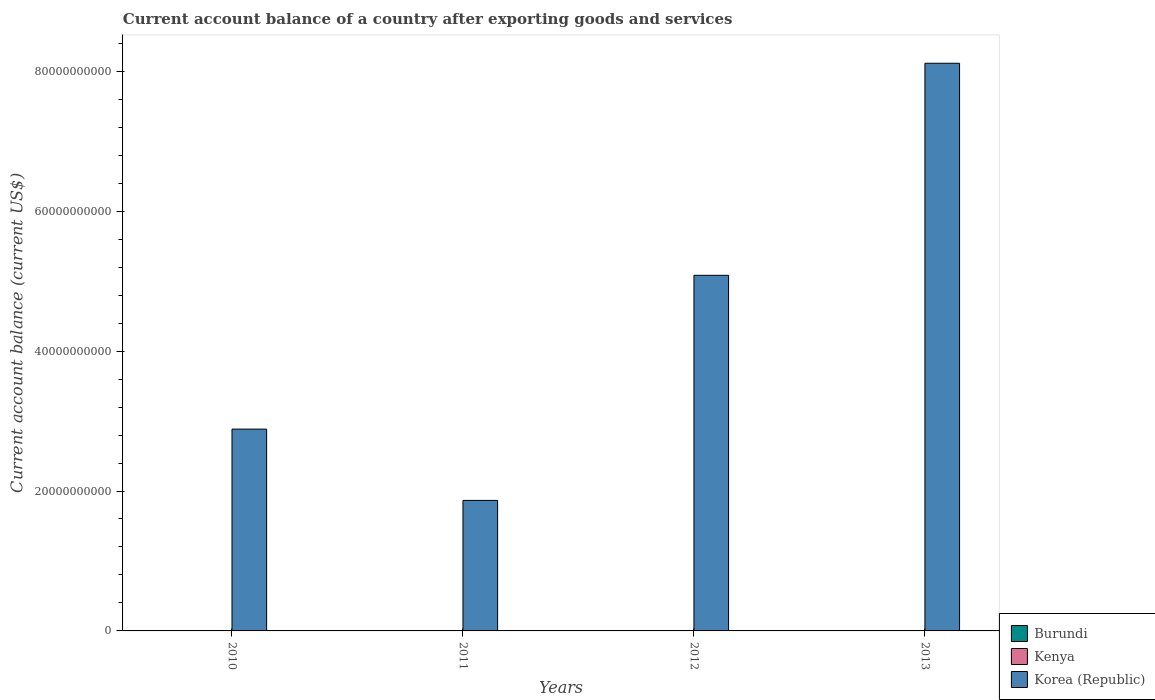How many different coloured bars are there?
Give a very brief answer. 1. Are the number of bars per tick equal to the number of legend labels?
Offer a terse response. No. How many bars are there on the 3rd tick from the left?
Keep it short and to the point. 1. How many bars are there on the 1st tick from the right?
Offer a very short reply. 1. What is the account balance in Korea (Republic) in 2013?
Your answer should be compact. 8.11e+1. Across all years, what is the maximum account balance in Korea (Republic)?
Ensure brevity in your answer.  8.11e+1. Across all years, what is the minimum account balance in Kenya?
Give a very brief answer. 0. What is the total account balance in Burundi in the graph?
Offer a terse response. 0. What is the difference between the account balance in Korea (Republic) in 2011 and that in 2012?
Provide a succinct answer. -3.22e+1. What is the difference between the account balance in Kenya in 2011 and the account balance in Korea (Republic) in 2013?
Provide a succinct answer. -8.11e+1. What is the average account balance in Kenya per year?
Offer a very short reply. 0. In how many years, is the account balance in Kenya greater than 24000000000 US$?
Make the answer very short. 0. What is the ratio of the account balance in Korea (Republic) in 2010 to that in 2011?
Keep it short and to the point. 1.55. Is the account balance in Korea (Republic) in 2010 less than that in 2011?
Your answer should be very brief. No. What is the difference between the highest and the second highest account balance in Korea (Republic)?
Make the answer very short. 3.03e+1. What is the difference between the highest and the lowest account balance in Korea (Republic)?
Your response must be concise. 6.25e+1. In how many years, is the account balance in Burundi greater than the average account balance in Burundi taken over all years?
Offer a very short reply. 0. How many bars are there?
Your response must be concise. 4. Are all the bars in the graph horizontal?
Ensure brevity in your answer.  No. What is the difference between two consecutive major ticks on the Y-axis?
Your answer should be compact. 2.00e+1. Where does the legend appear in the graph?
Provide a short and direct response. Bottom right. How many legend labels are there?
Keep it short and to the point. 3. What is the title of the graph?
Your answer should be compact. Current account balance of a country after exporting goods and services. Does "Kyrgyz Republic" appear as one of the legend labels in the graph?
Offer a terse response. No. What is the label or title of the X-axis?
Provide a succinct answer. Years. What is the label or title of the Y-axis?
Keep it short and to the point. Current account balance (current US$). What is the Current account balance (current US$) of Korea (Republic) in 2010?
Offer a very short reply. 2.89e+1. What is the Current account balance (current US$) in Kenya in 2011?
Provide a succinct answer. 0. What is the Current account balance (current US$) in Korea (Republic) in 2011?
Offer a terse response. 1.87e+1. What is the Current account balance (current US$) of Burundi in 2012?
Ensure brevity in your answer.  0. What is the Current account balance (current US$) in Kenya in 2012?
Make the answer very short. 0. What is the Current account balance (current US$) in Korea (Republic) in 2012?
Keep it short and to the point. 5.08e+1. What is the Current account balance (current US$) of Kenya in 2013?
Offer a terse response. 0. What is the Current account balance (current US$) of Korea (Republic) in 2013?
Provide a succinct answer. 8.11e+1. Across all years, what is the maximum Current account balance (current US$) of Korea (Republic)?
Offer a terse response. 8.11e+1. Across all years, what is the minimum Current account balance (current US$) of Korea (Republic)?
Ensure brevity in your answer.  1.87e+1. What is the total Current account balance (current US$) of Kenya in the graph?
Your response must be concise. 0. What is the total Current account balance (current US$) in Korea (Republic) in the graph?
Your answer should be very brief. 1.79e+11. What is the difference between the Current account balance (current US$) in Korea (Republic) in 2010 and that in 2011?
Provide a short and direct response. 1.02e+1. What is the difference between the Current account balance (current US$) in Korea (Republic) in 2010 and that in 2012?
Provide a short and direct response. -2.20e+1. What is the difference between the Current account balance (current US$) in Korea (Republic) in 2010 and that in 2013?
Your response must be concise. -5.23e+1. What is the difference between the Current account balance (current US$) of Korea (Republic) in 2011 and that in 2012?
Make the answer very short. -3.22e+1. What is the difference between the Current account balance (current US$) in Korea (Republic) in 2011 and that in 2013?
Make the answer very short. -6.25e+1. What is the difference between the Current account balance (current US$) in Korea (Republic) in 2012 and that in 2013?
Provide a succinct answer. -3.03e+1. What is the average Current account balance (current US$) of Burundi per year?
Provide a succinct answer. 0. What is the average Current account balance (current US$) in Korea (Republic) per year?
Provide a succinct answer. 4.49e+1. What is the ratio of the Current account balance (current US$) in Korea (Republic) in 2010 to that in 2011?
Make the answer very short. 1.55. What is the ratio of the Current account balance (current US$) in Korea (Republic) in 2010 to that in 2012?
Make the answer very short. 0.57. What is the ratio of the Current account balance (current US$) in Korea (Republic) in 2010 to that in 2013?
Your answer should be compact. 0.36. What is the ratio of the Current account balance (current US$) of Korea (Republic) in 2011 to that in 2012?
Ensure brevity in your answer.  0.37. What is the ratio of the Current account balance (current US$) in Korea (Republic) in 2011 to that in 2013?
Your response must be concise. 0.23. What is the ratio of the Current account balance (current US$) in Korea (Republic) in 2012 to that in 2013?
Give a very brief answer. 0.63. What is the difference between the highest and the second highest Current account balance (current US$) of Korea (Republic)?
Your answer should be very brief. 3.03e+1. What is the difference between the highest and the lowest Current account balance (current US$) in Korea (Republic)?
Keep it short and to the point. 6.25e+1. 